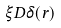Convert formula to latex. <formula><loc_0><loc_0><loc_500><loc_500>\xi D \delta ( \vec { r } )</formula> 